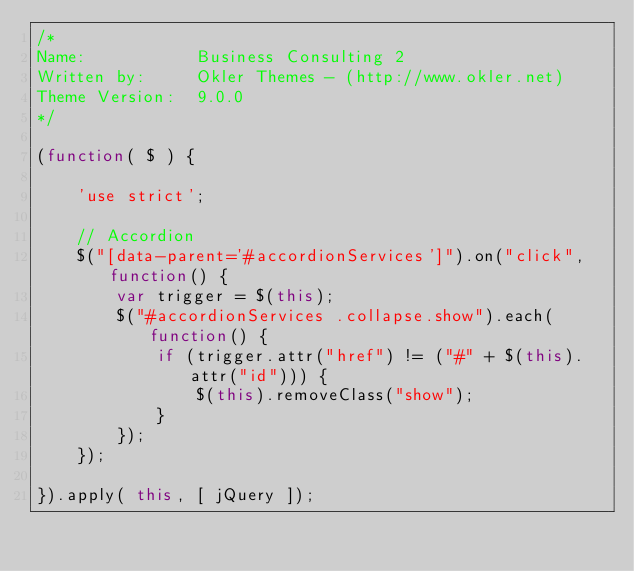Convert code to text. <code><loc_0><loc_0><loc_500><loc_500><_JavaScript_>/*
Name: 			Business Consulting 2
Written by: 	Okler Themes - (http://www.okler.net)
Theme Version:	9.0.0
*/

(function( $ ) {

	'use strict';

	// Accordion
	$("[data-parent='#accordionServices']").on("click", function() {
		var trigger = $(this);
		$("#accordionServices .collapse.show").each(function() {
			if (trigger.attr("href") != ("#" + $(this).attr("id"))) {
				$(this).removeClass("show");
			}
		});
	});
	
}).apply( this, [ jQuery ]);</code> 